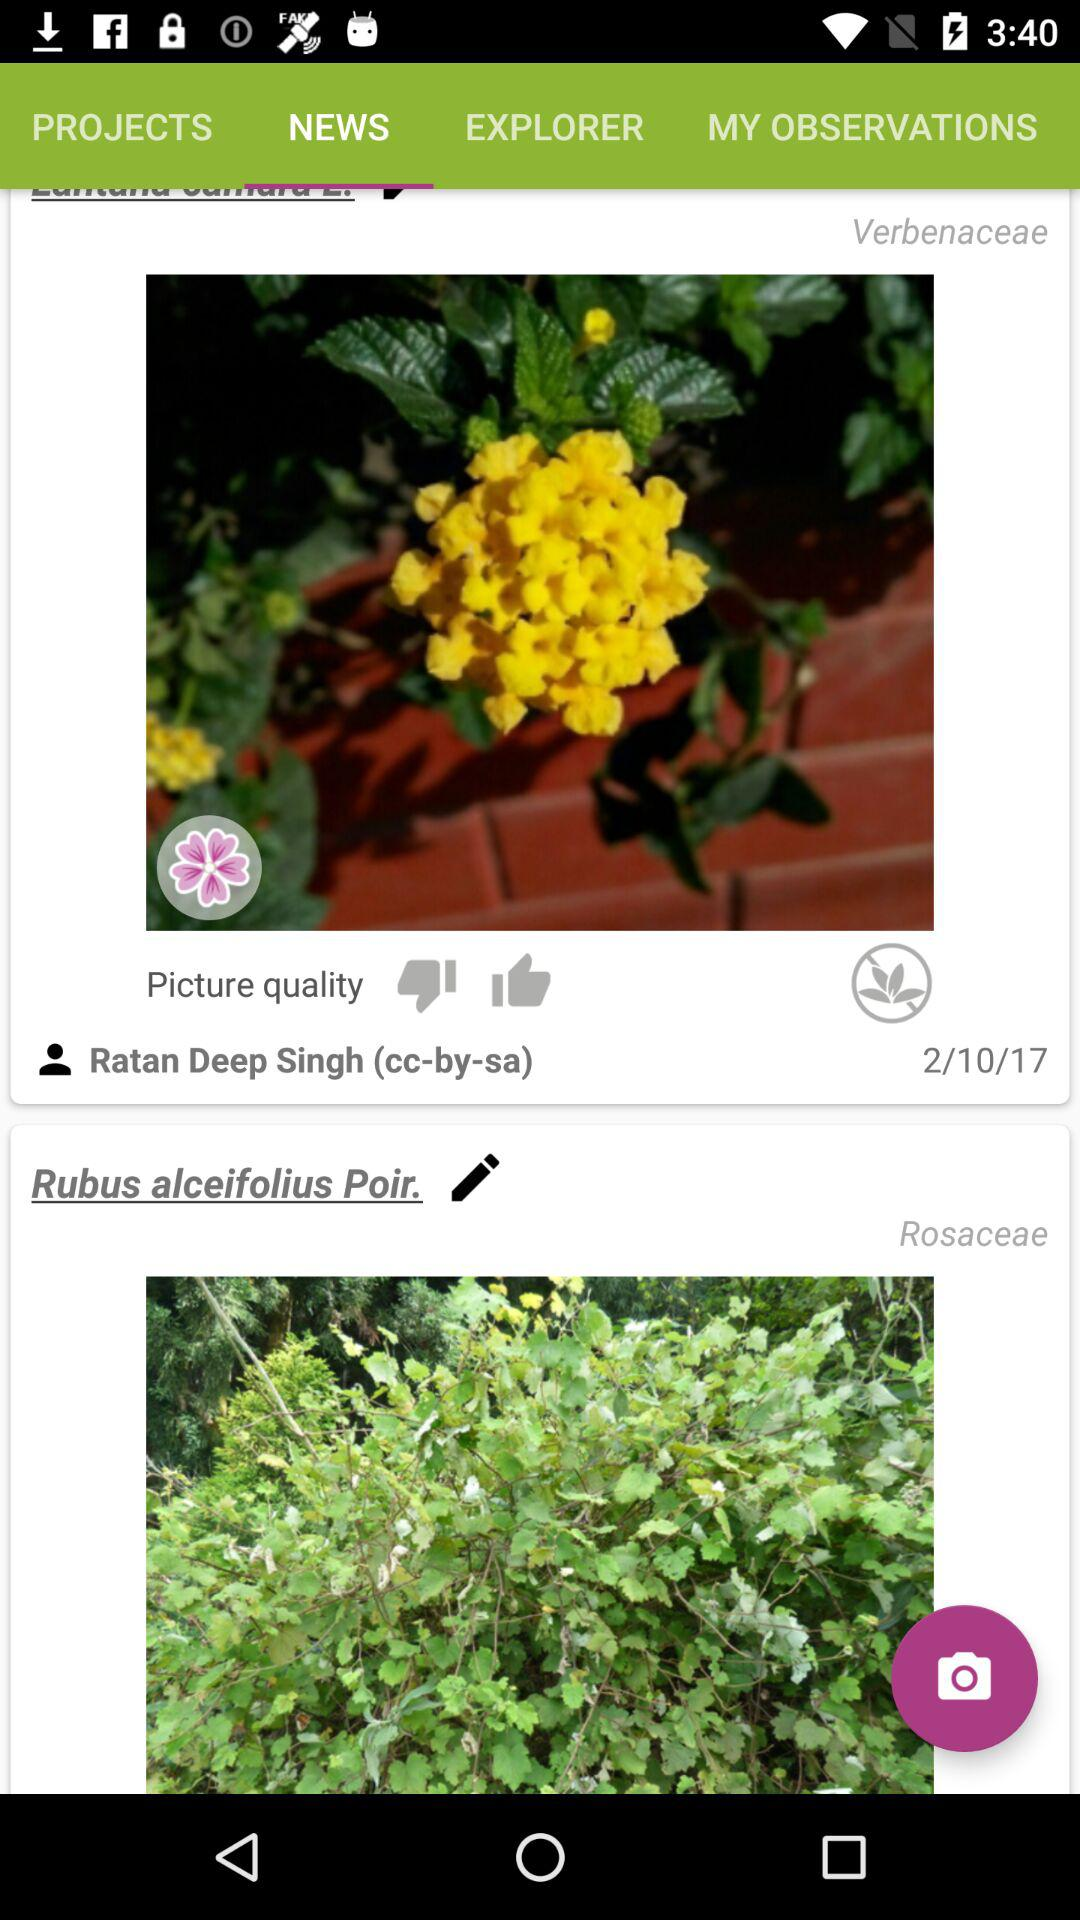Which tab is selected? The selected tab is "NEWS". 